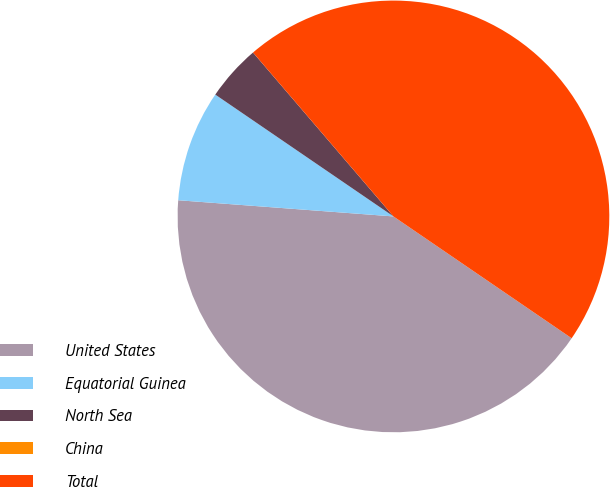<chart> <loc_0><loc_0><loc_500><loc_500><pie_chart><fcel>United States<fcel>Equatorial Guinea<fcel>North Sea<fcel>China<fcel>Total<nl><fcel>41.65%<fcel>8.35%<fcel>4.18%<fcel>0.0%<fcel>45.82%<nl></chart> 